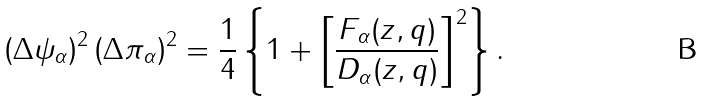Convert formula to latex. <formula><loc_0><loc_0><loc_500><loc_500>\left ( \Delta \psi _ { \alpha } \right ) ^ { 2 } \left ( \Delta \pi _ { \alpha } \right ) ^ { 2 } = \frac { 1 } { 4 } \left \{ 1 + \left [ \frac { F _ { \alpha } ( z , q ) } { D _ { \alpha } ( z , q ) } \right ] ^ { 2 } \right \} .</formula> 